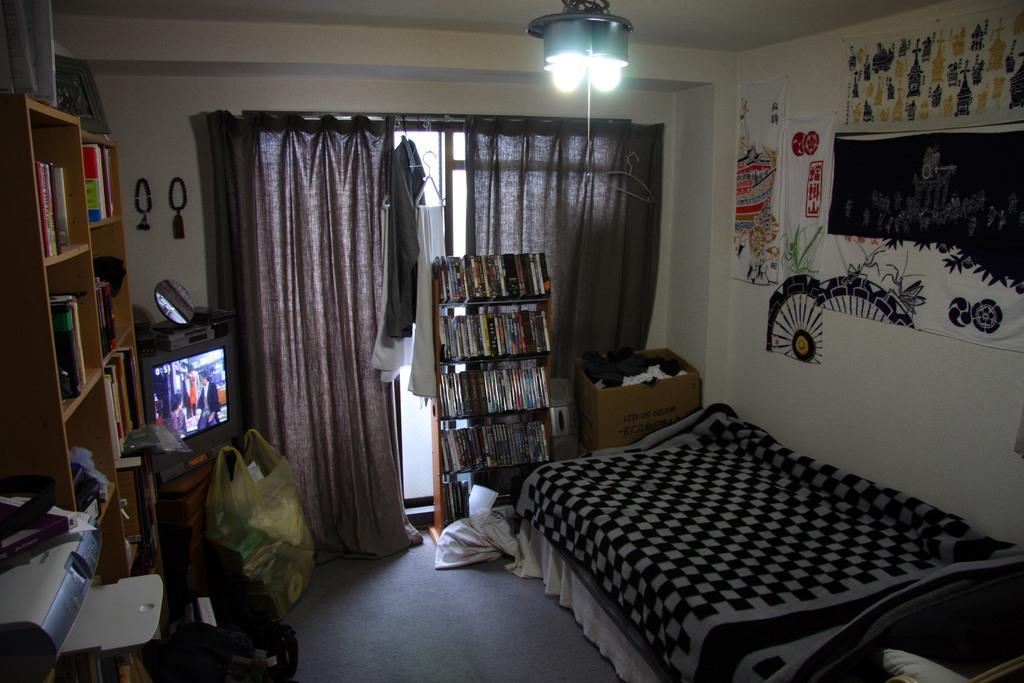Can you describe this image briefly? Here in this picture we can see a bed present on the right side and on the wall we can see some paintings present and in the middle we can see books present in the rack over there and behind that we can see curtains covered over there door and on the roof we can see lights present and on the left side we can see television present on the table and on that we can see a mirror and beside that we can see shelves that are fully covered with books over there and we can see some bags and covers present on the floor and we can also see other things present over there. 